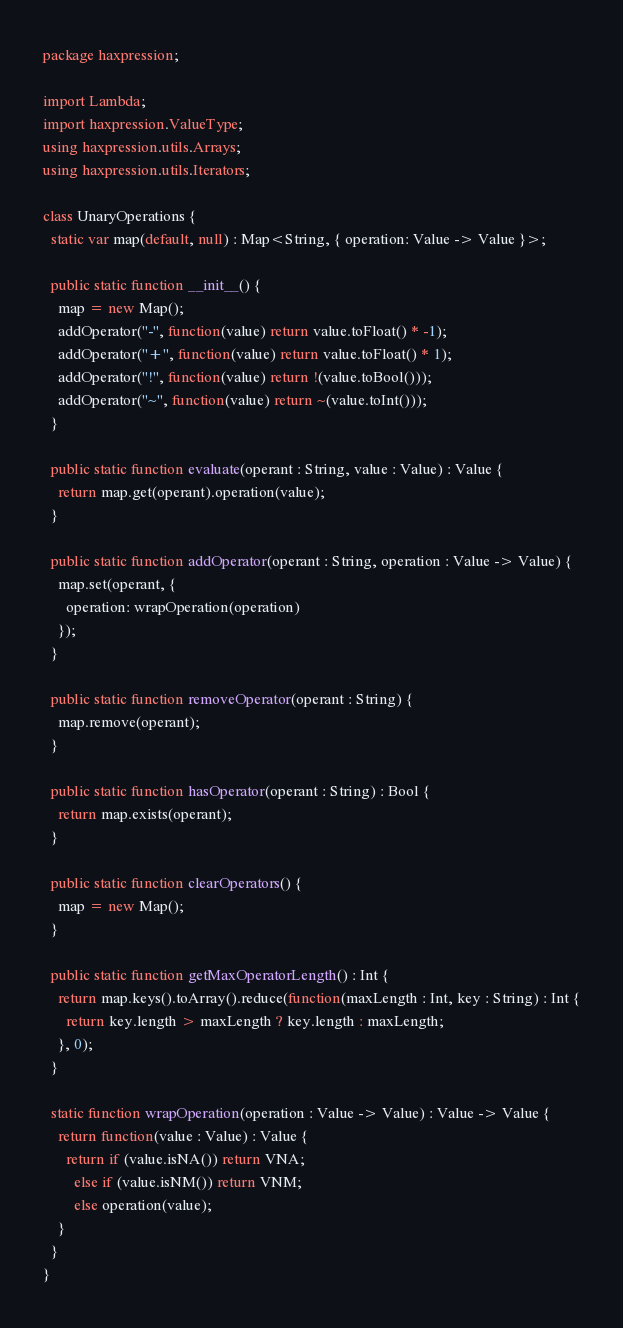Convert code to text. <code><loc_0><loc_0><loc_500><loc_500><_Haxe_>package haxpression;

import Lambda;
import haxpression.ValueType;
using haxpression.utils.Arrays;
using haxpression.utils.Iterators;

class UnaryOperations {
  static var map(default, null) : Map<String, { operation: Value -> Value }>;

  public static function __init__() {
    map = new Map();
    addOperator("-", function(value) return value.toFloat() * -1);
    addOperator("+", function(value) return value.toFloat() * 1);
    addOperator("!", function(value) return !(value.toBool()));
    addOperator("~", function(value) return ~(value.toInt()));
  }

  public static function evaluate(operant : String, value : Value) : Value {
    return map.get(operant).operation(value);
  }

  public static function addOperator(operant : String, operation : Value -> Value) {
    map.set(operant, {
      operation: wrapOperation(operation)
    });
  }

  public static function removeOperator(operant : String) {
    map.remove(operant);
  }

  public static function hasOperator(operant : String) : Bool {
    return map.exists(operant);
  }

  public static function clearOperators() {
    map = new Map();
  }

  public static function getMaxOperatorLength() : Int {
    return map.keys().toArray().reduce(function(maxLength : Int, key : String) : Int {
      return key.length > maxLength ? key.length : maxLength;
    }, 0);
  }

  static function wrapOperation(operation : Value -> Value) : Value -> Value {
    return function(value : Value) : Value {
      return if (value.isNA()) return VNA;
        else if (value.isNM()) return VNM;
        else operation(value);
    }
  }
}
</code> 